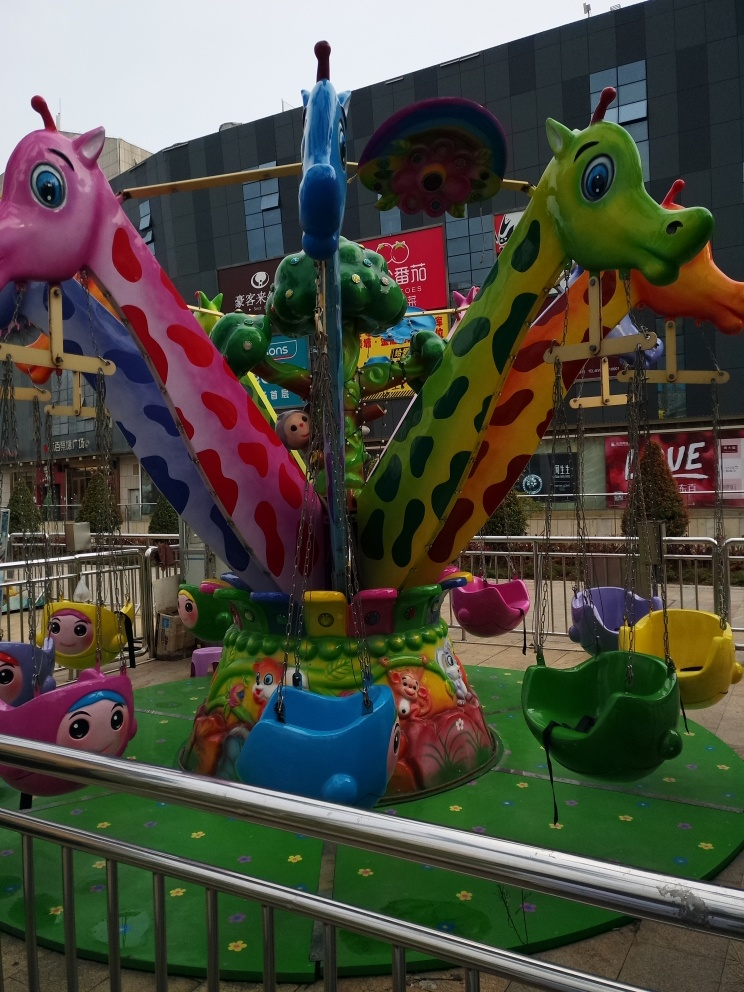What time of the year or day does this image suggest? There are no clear indications of the time of year, as no seasonal decorations or weather-related hints are visible. However, the brightly lit surroundings and lack of shadows suggest it could be on a cloudy day or in indirect sunlight, likely during daytime hours. 